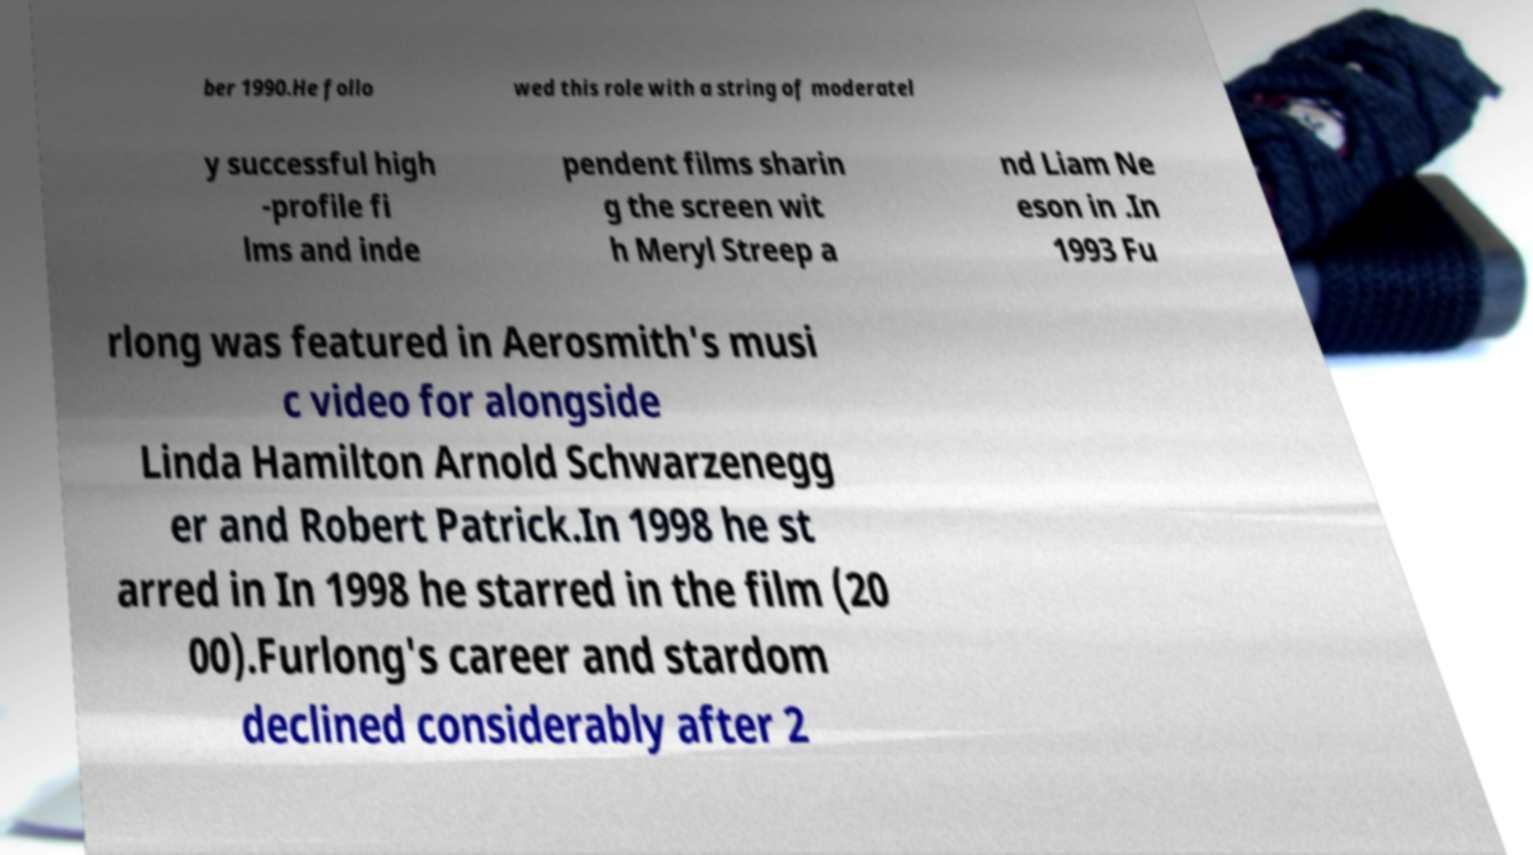What messages or text are displayed in this image? I need them in a readable, typed format. ber 1990.He follo wed this role with a string of moderatel y successful high -profile fi lms and inde pendent films sharin g the screen wit h Meryl Streep a nd Liam Ne eson in .In 1993 Fu rlong was featured in Aerosmith's musi c video for alongside Linda Hamilton Arnold Schwarzenegg er and Robert Patrick.In 1998 he st arred in In 1998 he starred in the film (20 00).Furlong's career and stardom declined considerably after 2 